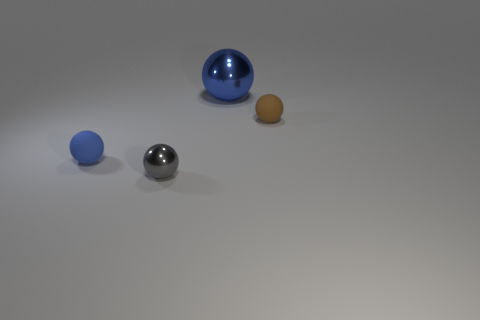There is a tiny gray object in front of the small blue rubber ball; what material is it?
Offer a very short reply. Metal. There is a matte thing that is the same size as the brown rubber sphere; what is its color?
Provide a short and direct response. Blue. How many other things are the same shape as the small gray metallic thing?
Provide a succinct answer. 3. Is the size of the blue matte ball the same as the blue metallic object?
Your response must be concise. No. Is the number of tiny blue objects that are behind the tiny shiny ball greater than the number of large metal objects behind the big sphere?
Your answer should be very brief. Yes. What number of other things are the same size as the blue matte object?
Make the answer very short. 2. Is the color of the small matte ball to the left of the big blue metal thing the same as the big thing?
Provide a short and direct response. Yes. Are there more small metallic balls behind the blue shiny object than metal balls?
Offer a very short reply. No. Are there any other things that are the same color as the large sphere?
Make the answer very short. Yes. Are there more large blue shiny spheres than green rubber objects?
Provide a succinct answer. Yes. 